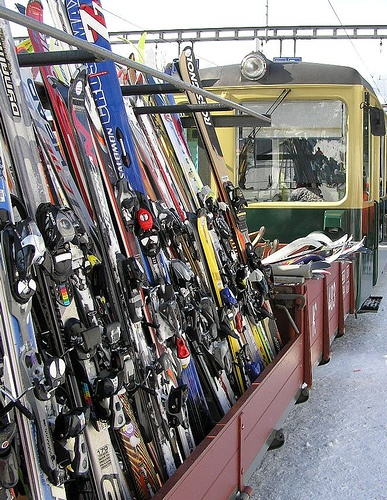Describe the objects in this image and their specific colors. I can see train in darkgray, gray, black, and tan tones, snowboard in darkgray, black, blue, and white tones, skis in darkgray, black, gray, and ivory tones, skis in darkgray, lightgray, gray, and beige tones, and snowboard in darkgray, lightgray, and black tones in this image. 